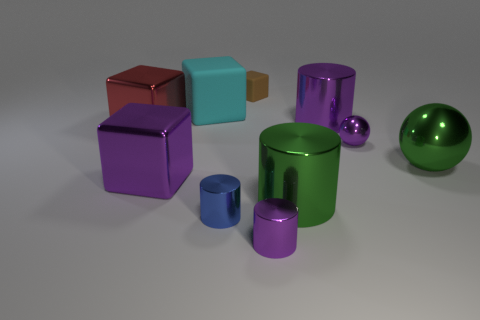There is a object that is behind the large cyan matte object; what color is it?
Provide a succinct answer. Brown. Are there any other things that are the same shape as the brown thing?
Your answer should be very brief. Yes. What is the size of the cylinder on the right side of the big object that is in front of the purple shiny cube?
Make the answer very short. Large. Are there an equal number of rubber cubes that are behind the small rubber cube and small shiny cylinders on the right side of the purple metallic sphere?
Your answer should be compact. Yes. Is there anything else that has the same size as the purple ball?
Your response must be concise. Yes. What is the color of the large ball that is the same material as the small blue object?
Provide a short and direct response. Green. Does the tiny purple cylinder have the same material as the small object behind the cyan block?
Offer a terse response. No. What is the color of the large metallic thing that is both behind the big ball and to the left of the blue metallic object?
Your answer should be compact. Red. How many cylinders are either large red shiny things or cyan matte things?
Offer a very short reply. 0. There is a large red metal thing; is its shape the same as the big rubber object that is left of the tiny matte block?
Offer a terse response. Yes. 